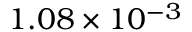Convert formula to latex. <formula><loc_0><loc_0><loc_500><loc_500>1 . 0 8 \times 1 0 ^ { - 3 }</formula> 